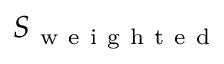<formula> <loc_0><loc_0><loc_500><loc_500>S _ { w e i g h t e d }</formula> 